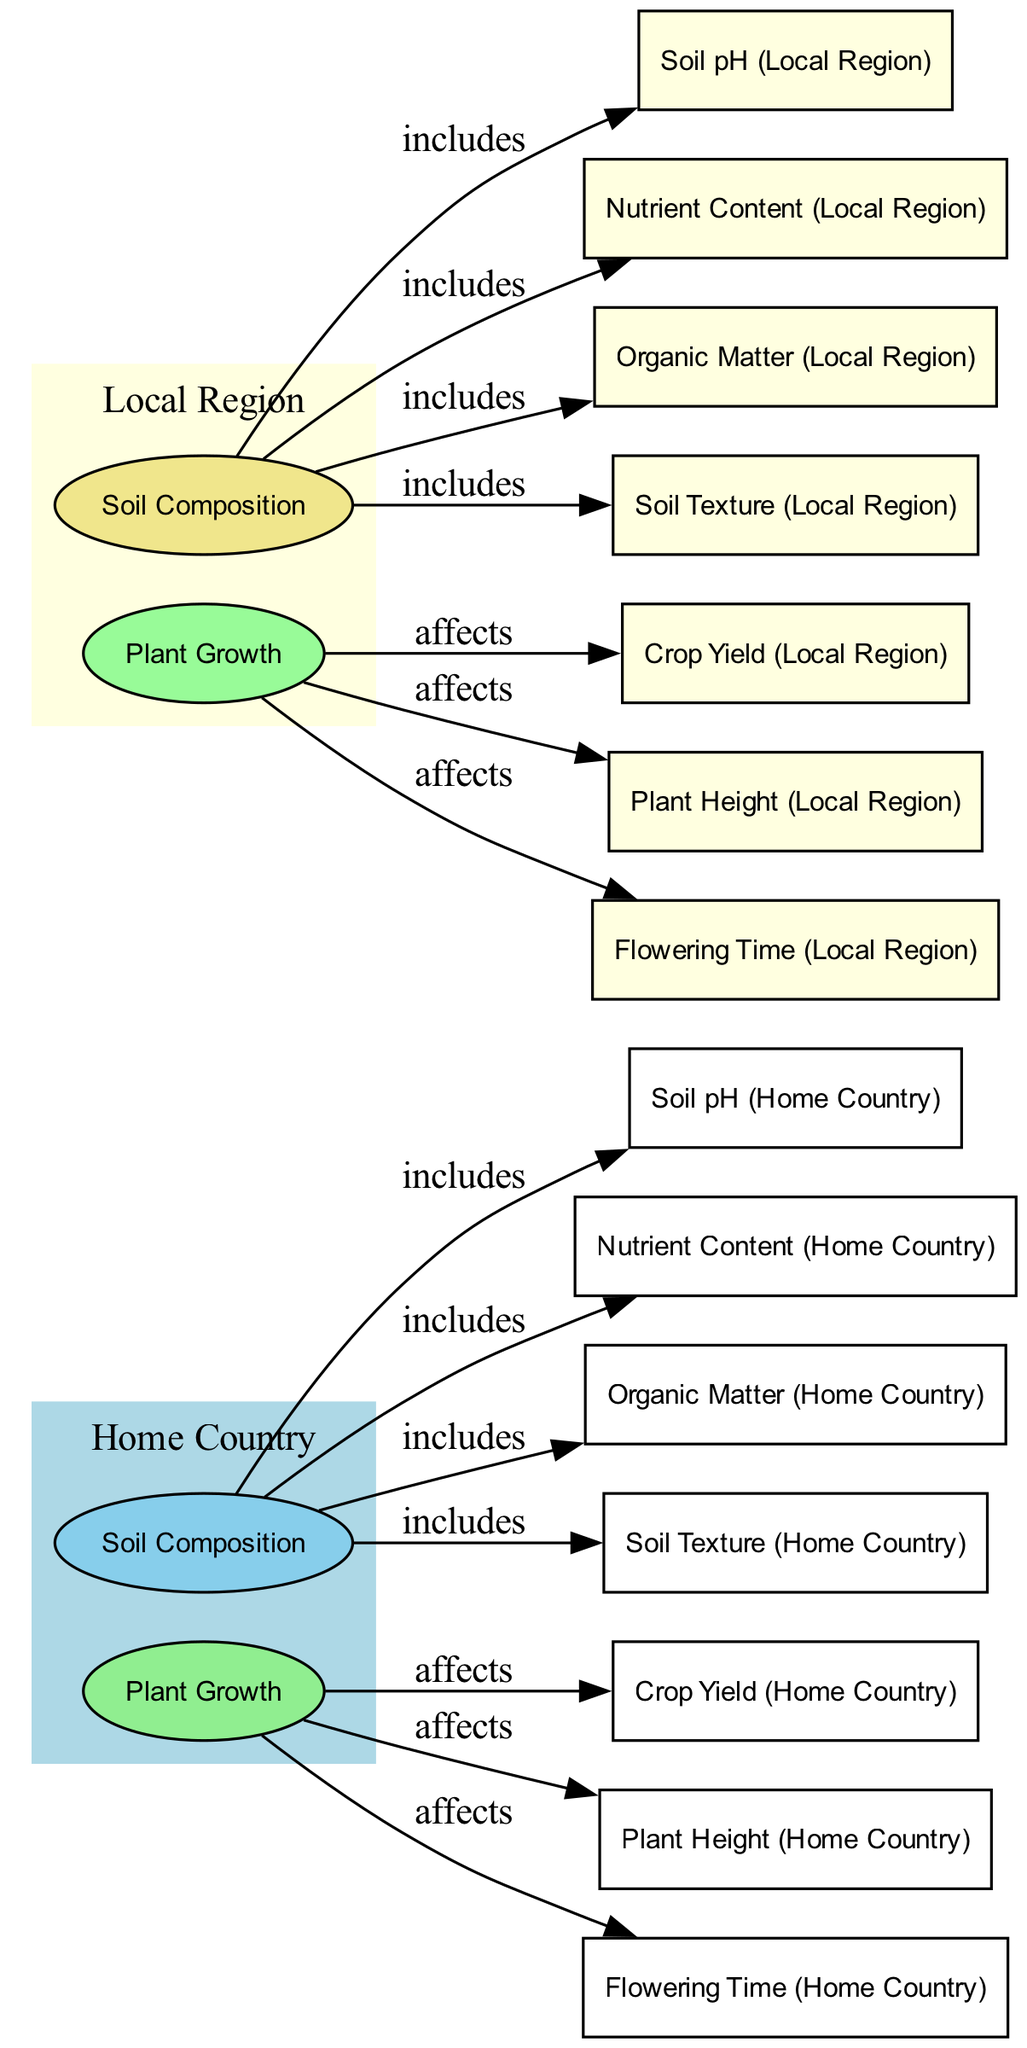What is the primary factor that affects crop yield in the home country? The diagram indicates that 'Plant Growth (Home Country)' affects 'Crop Yield (Home Country)'. The primary factor related to crop yield is thus plant growth.
Answer: Plant Growth (Home Country) What type of soil texture is represented for the local region? From the nodes, 'Soil Texture (Local Region)' can be identified. As it is a data node and typically describes the soil structure, the diagram would provide details of this specific texture.
Answer: Soil Texture (Local Region) How many nodes represent the soil composition for both regions? By counting the nodes under 'Soil Composition (Home Country)' and 'Soil Composition (Local Region)', there are four nodes regarding soil composition: soil pH, nutrient content, organic matter, and soil texture for each region. Thus, a total of eight nodes represent soil composition across both regions.
Answer: Eight What is the relationship between soil pH and nutrient content in the home country? The diagram shows that both 'Soil Composition (Home Country)' includes 'Soil pH (Home Country)' and 'Nutrient Content (Home Country)'. Hence, the soil pH is related to the nutrient content as part of the overall soil composition.
Answer: Includes Which factor shows a difference in flowering time between the two regions? The nodes 'Flowering Time (Home Country)' and 'Flowering Time (Local Region)' indicate that flowering time is part of plant growth and highlights differences in growth patterns between the two regions.
Answer: Flowering Time Which region shows a higher organic matter content? To answer this, one would refer to 'Organic Matter (Home Country)' and 'Organic Matter (Local Region)'. The labels will provide a direct comparison indicating which region has more organic matter based on visual data.
Answer: Organic Matter Comparison What is the effect of soil composition on plant height in the local region? The diagram indicates that 'Plant Growth (Local Region)' affects 'Plant Height (Local Region)', meaning the composition and characteristics of the soil influence how tall plants grow in this region. Thus, by analyzing the nodes, one can deduce this relationship.
Answer: Affects What determines the overall plant growth in the local region? The diagram highlights that 'Soil Composition (Local Region)' directly impacts 'Plant Growth (Local Region)', indicating that the overall plant growth in the local region is determined by its soil composition.
Answer: Soil Composition (Local Region) 